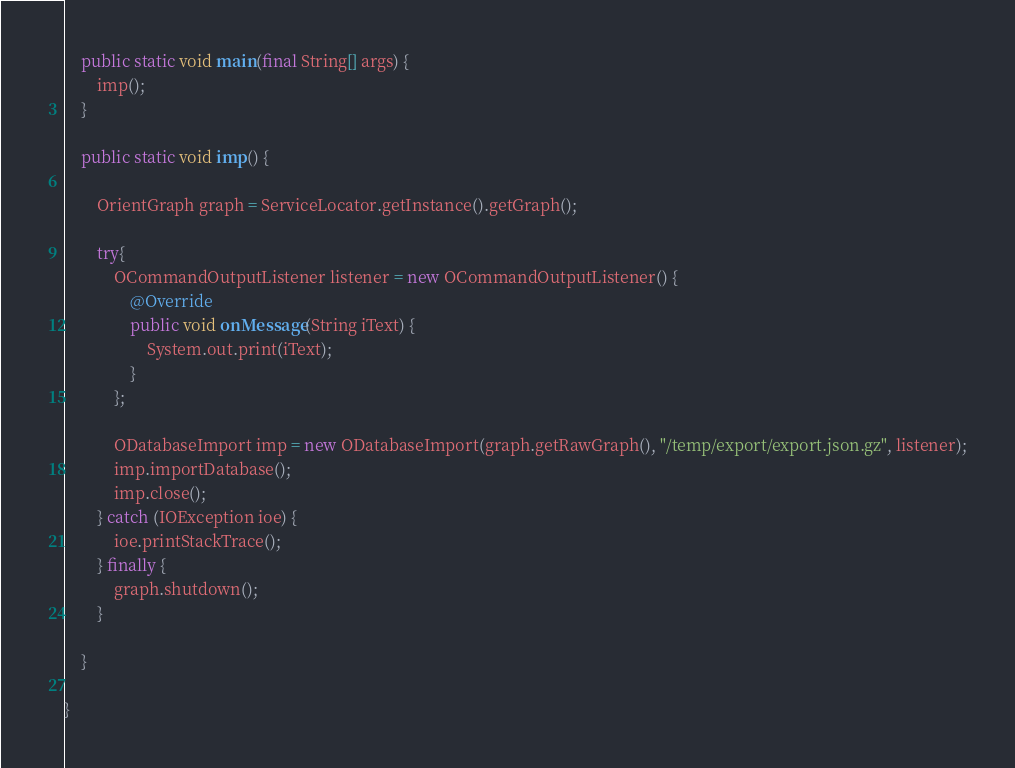<code> <loc_0><loc_0><loc_500><loc_500><_Java_>    public static void main(final String[] args) {
        imp();
    }

    public static void imp() {

        OrientGraph graph = ServiceLocator.getInstance().getGraph();

        try{
            OCommandOutputListener listener = new OCommandOutputListener() {
                @Override
                public void onMessage(String iText) {
                    System.out.print(iText);
                }
            };

            ODatabaseImport imp = new ODatabaseImport(graph.getRawGraph(), "/temp/export/export.json.gz", listener);
            imp.importDatabase();
            imp.close();
        } catch (IOException ioe) {
            ioe.printStackTrace();
        } finally {
            graph.shutdown();
        }

    }

}
</code> 